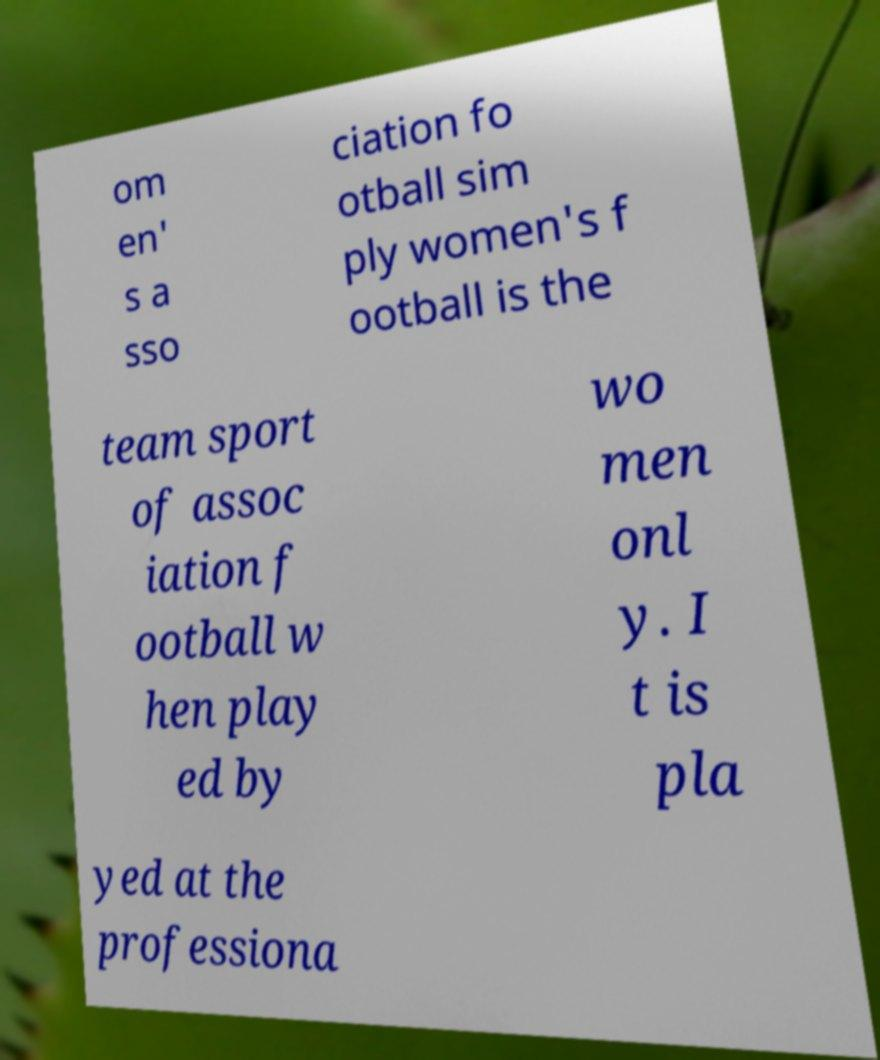For documentation purposes, I need the text within this image transcribed. Could you provide that? om en' s a sso ciation fo otball sim ply women's f ootball is the team sport of assoc iation f ootball w hen play ed by wo men onl y. I t is pla yed at the professiona 